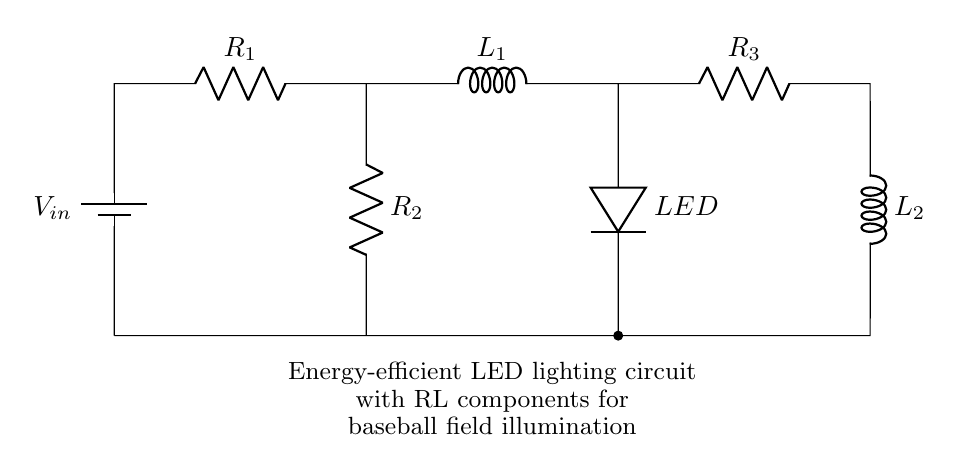What is the input voltage of this circuit? The input voltage is labeled as V_in in the circuit diagram, which indicates the source voltage supplied to the circuit.
Answer: V_in How many resistors are present in this circuit? The circuit shows three resistors labeled as R_1, R_2, and R_3. By counting these components, we can determine the total number of resistors.
Answer: 3 What is the role of the inductor L_1? The inductor L_1 is connected in series with R_1 and is used to manage current flow, providing inductive delay and filtering effects, which are characteristic roles of inductors in a circuit.
Answer: Manage current flow Which component is responsible for illumination? The component labeled as LED is responsible for providing illumination in this circuit, as it converts electrical energy into visible light.
Answer: LED What is the relationship between R_2 and the LED in terms of circuit path? R_2 is connected directly in parallel with the LED, indicating that the current through R_2 splits and some of it flows through the LED, allowing for controlled brightness.
Answer: Parallel connection Which inductor is located on the right side of the circuit? The inductor on the right side of the circuit is labeled as L_2, which is used alongside R_3 in a different part of the circuit, potentially for additional filtering or energy storage.
Answer: L_2 How does adding resistors impact the overall circuit behavior? Adding resistors like R_1, R_2, and R_3 affects the total resistance and current through the circuit according to Ohm’s law, which influences both the LED brightness and energy efficiency of the circuit overall.
Answer: Affects total resistance 